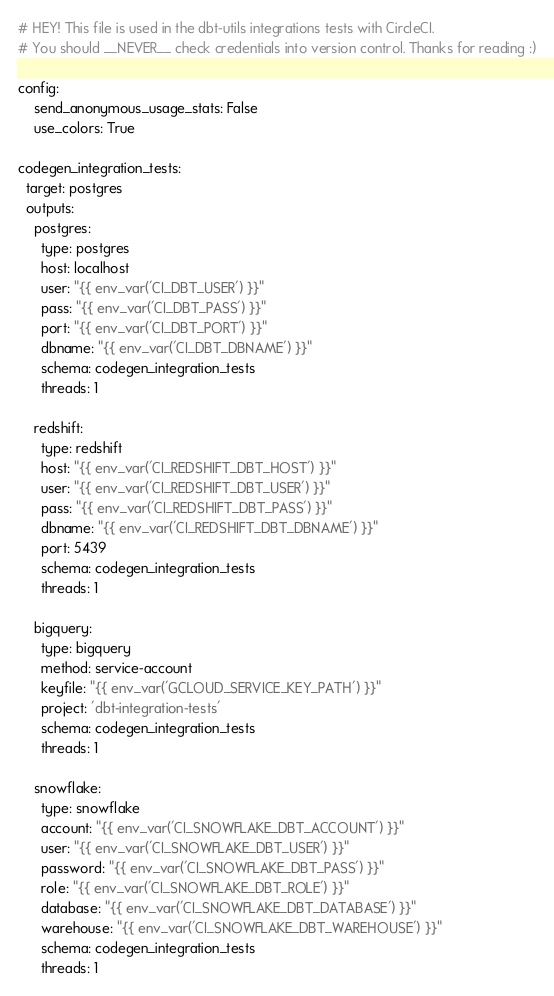Convert code to text. <code><loc_0><loc_0><loc_500><loc_500><_YAML_>
# HEY! This file is used in the dbt-utils integrations tests with CircleCI.
# You should __NEVER__ check credentials into version control. Thanks for reading :)

config:
    send_anonymous_usage_stats: False
    use_colors: True

codegen_integration_tests:
  target: postgres
  outputs:
    postgres:
      type: postgres
      host: localhost
      user: "{{ env_var('CI_DBT_USER') }}"
      pass: "{{ env_var('CI_DBT_PASS') }}"
      port: "{{ env_var('CI_DBT_PORT') }}"
      dbname: "{{ env_var('CI_DBT_DBNAME') }}"
      schema: codegen_integration_tests
      threads: 1

    redshift:
      type: redshift
      host: "{{ env_var('CI_REDSHIFT_DBT_HOST') }}"
      user: "{{ env_var('CI_REDSHIFT_DBT_USER') }}"
      pass: "{{ env_var('CI_REDSHIFT_DBT_PASS') }}"
      dbname: "{{ env_var('CI_REDSHIFT_DBT_DBNAME') }}"
      port: 5439
      schema: codegen_integration_tests
      threads: 1

    bigquery:
      type: bigquery
      method: service-account
      keyfile: "{{ env_var('GCLOUD_SERVICE_KEY_PATH') }}"
      project: 'dbt-integration-tests'
      schema: codegen_integration_tests
      threads: 1

    snowflake:
      type: snowflake
      account: "{{ env_var('CI_SNOWFLAKE_DBT_ACCOUNT') }}"
      user: "{{ env_var('CI_SNOWFLAKE_DBT_USER') }}"
      password: "{{ env_var('CI_SNOWFLAKE_DBT_PASS') }}"
      role: "{{ env_var('CI_SNOWFLAKE_DBT_ROLE') }}"
      database: "{{ env_var('CI_SNOWFLAKE_DBT_DATABASE') }}"
      warehouse: "{{ env_var('CI_SNOWFLAKE_DBT_WAREHOUSE') }}"
      schema: codegen_integration_tests
      threads: 1
</code> 